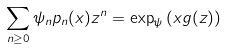<formula> <loc_0><loc_0><loc_500><loc_500>\sum _ { n \geq 0 } \psi _ { n } p _ { n } ( x ) z ^ { n } = \exp _ { \psi } \left ( x g ( z ) \right )</formula> 